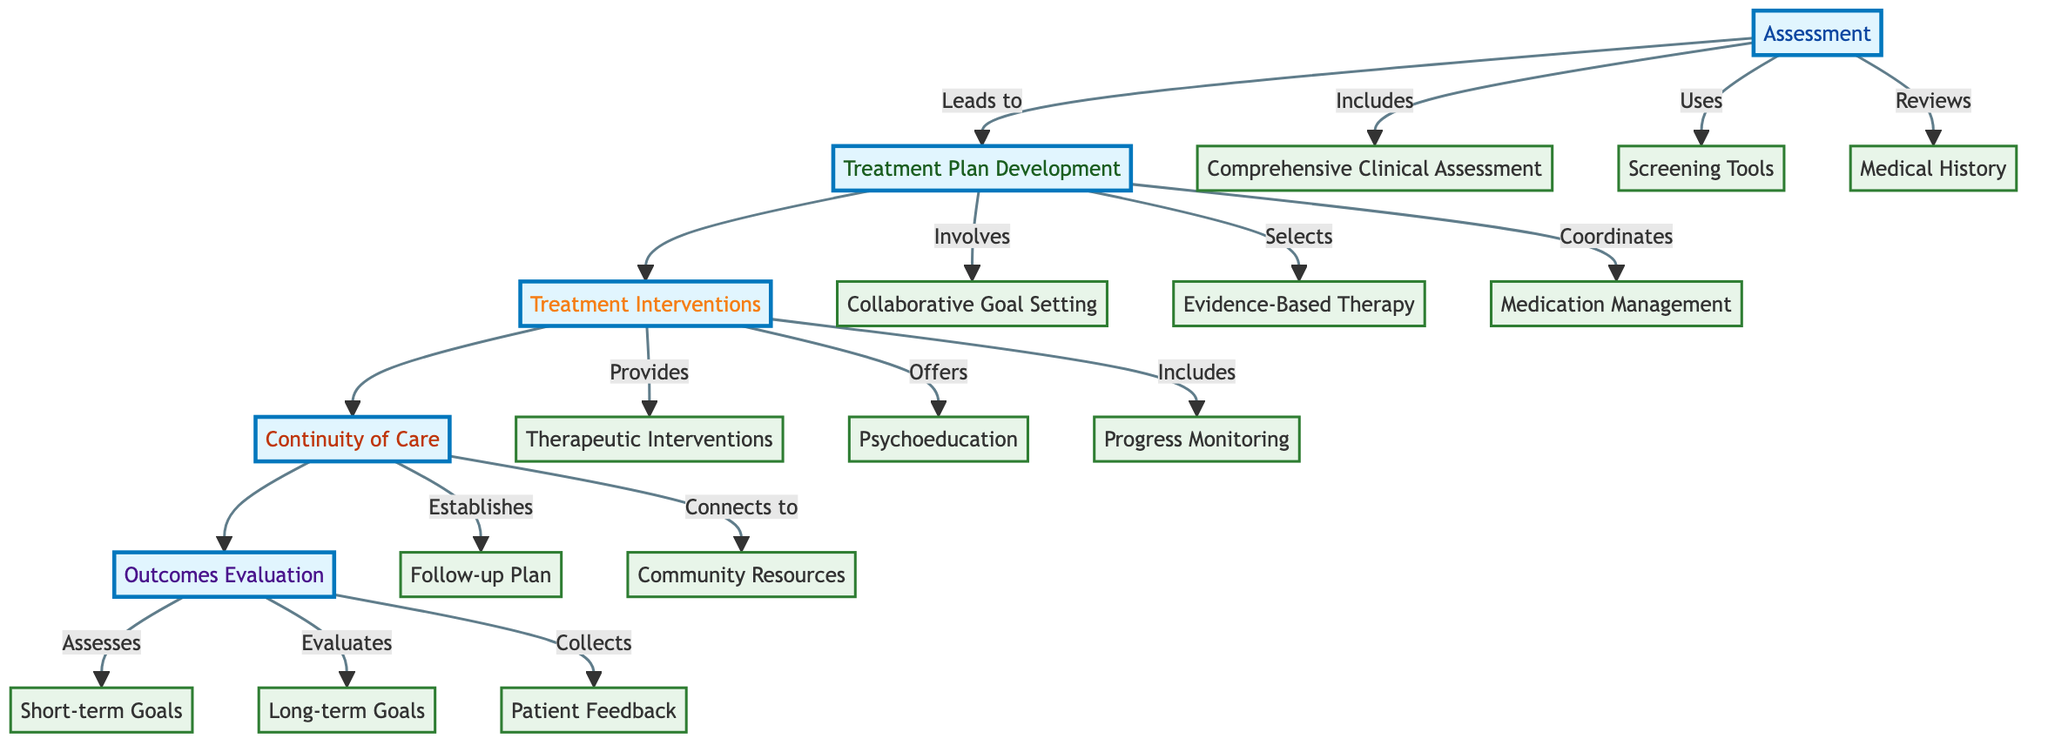What is the first step in the process? The first step in the Clinical Pathway is "Assessment," which initiates the whole process leading to the development of a treatment plan.
Answer: Assessment How many screening tools are used in the assessment phase? In the assessment phase, three screening tools are indicated: PTSD Checklist for DSM-5 (PCL-5), Beck Depression Inventory (BDI), and Generalized Anxiety Disorder 7 (GAD-7).
Answer: 3 What follows after "Treatment Plan Development"? The next step after "Treatment Plan Development" is "Treatment Interventions," which includes actions based on the formulated treatment plan.
Answer: Treatment Interventions Which interventions are included under "Therapeutic Interventions"? Under "Therapeutic Interventions," the interventions listed include "Weekly Individual Therapy Sessions," "Group Therapy Options," and "Family Therapy."
Answer: Weekly Individual Therapy Sessions, Group Therapy Options, Family Therapy What is the purpose of the "Follow-up Plan"? The "Follow-up Plan" aims to ensure continuity of care through scheduling monthly follow-up appointments and providing 24/7 crisis hotline access.
Answer: Continuity of care How does "Patient Feedback" contribute to the outcomes evaluation? "Patient Feedback" involves collecting responses through satisfaction surveys, thereby assessing how the patient perceives the effectiveness of the treatment received.
Answer: Patient Satisfaction Surveys What are the short-term goals evaluated in the outcomes phase? The short-term goals evaluated include "Reduction in PTSD Symptoms" and "Improvement in Daily Functioning," focusing on immediate therapeutic outcomes.
Answer: Reduction in PTSD Symptoms, Improvement in Daily Functioning What is the overarching goal of the treatment plan? The overarching goal of the treatment plan is "Sustained Symptom Management," which aligns with the therapeutic aim of maintaining long-term mental health stability.
Answer: Sustained Symptom Management Which therapeutic approach is highlighted for evidence-based therapy selection? The highlighted therapeutic approaches for evidence-based therapy selection include "Cognitive Behavioral Therapy (CBT)," "Eye Movement Desensitization and Reprocessing (EMDR)," and "Trauma-Focused Cognitive Behavioral Therapy (TF-CBT)."
Answer: Cognitive Behavioral Therapy (CBT), Eye Movement Desensitization and Reprocessing (EMDR), Trauma-Focused Cognitive Behavioral Therapy (TF-CBT) 